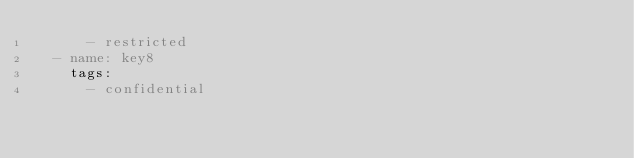<code> <loc_0><loc_0><loc_500><loc_500><_YAML_>      - restricted
  - name: key8
    tags:
      - confidential

</code> 